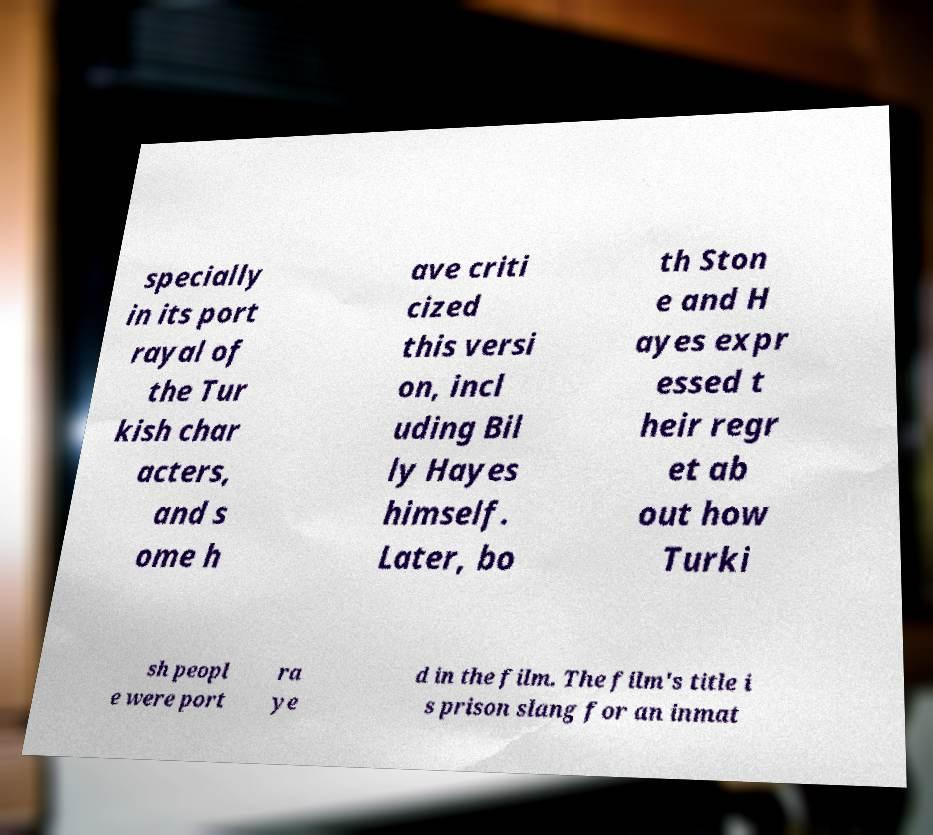Please read and relay the text visible in this image. What does it say? specially in its port rayal of the Tur kish char acters, and s ome h ave criti cized this versi on, incl uding Bil ly Hayes himself. Later, bo th Ston e and H ayes expr essed t heir regr et ab out how Turki sh peopl e were port ra ye d in the film. The film's title i s prison slang for an inmat 